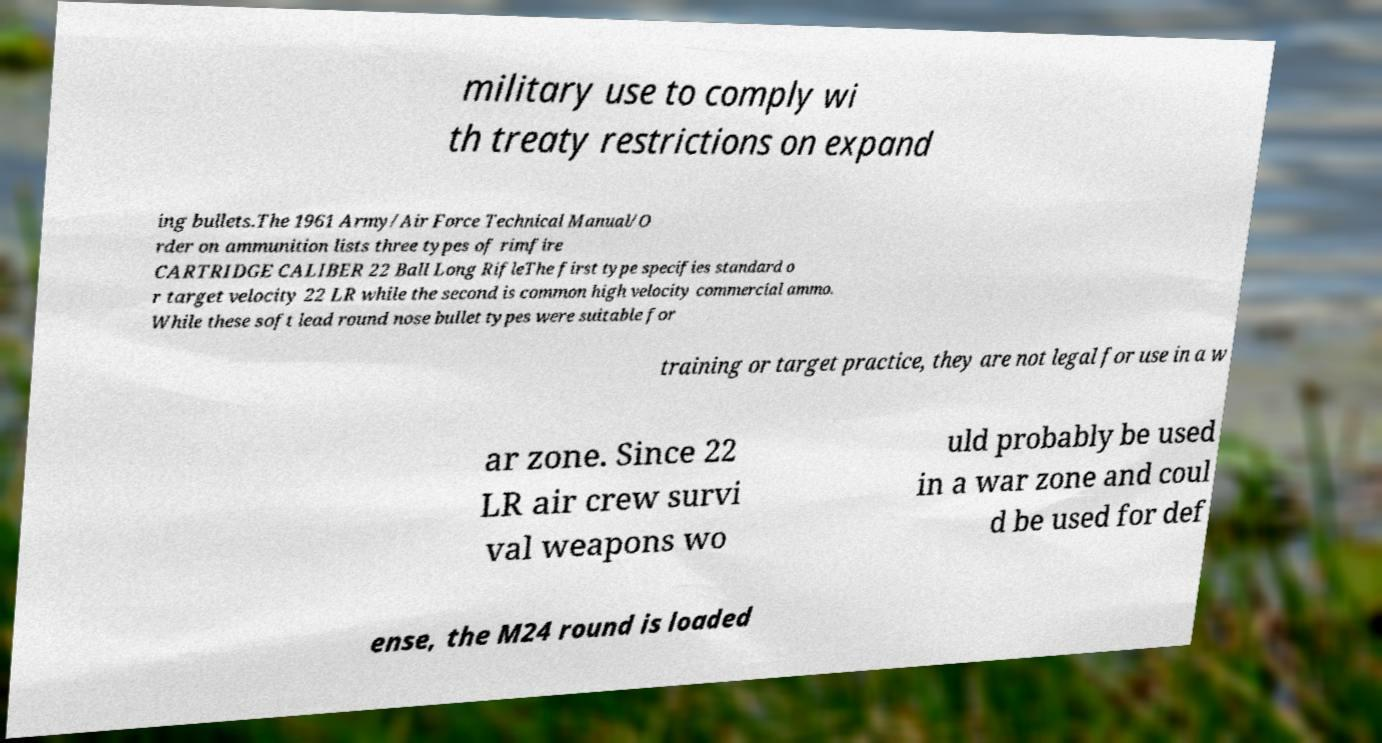Can you read and provide the text displayed in the image?This photo seems to have some interesting text. Can you extract and type it out for me? military use to comply wi th treaty restrictions on expand ing bullets.The 1961 Army/Air Force Technical Manual/O rder on ammunition lists three types of rimfire CARTRIDGE CALIBER 22 Ball Long RifleThe first type specifies standard o r target velocity 22 LR while the second is common high velocity commercial ammo. While these soft lead round nose bullet types were suitable for training or target practice, they are not legal for use in a w ar zone. Since 22 LR air crew survi val weapons wo uld probably be used in a war zone and coul d be used for def ense, the M24 round is loaded 